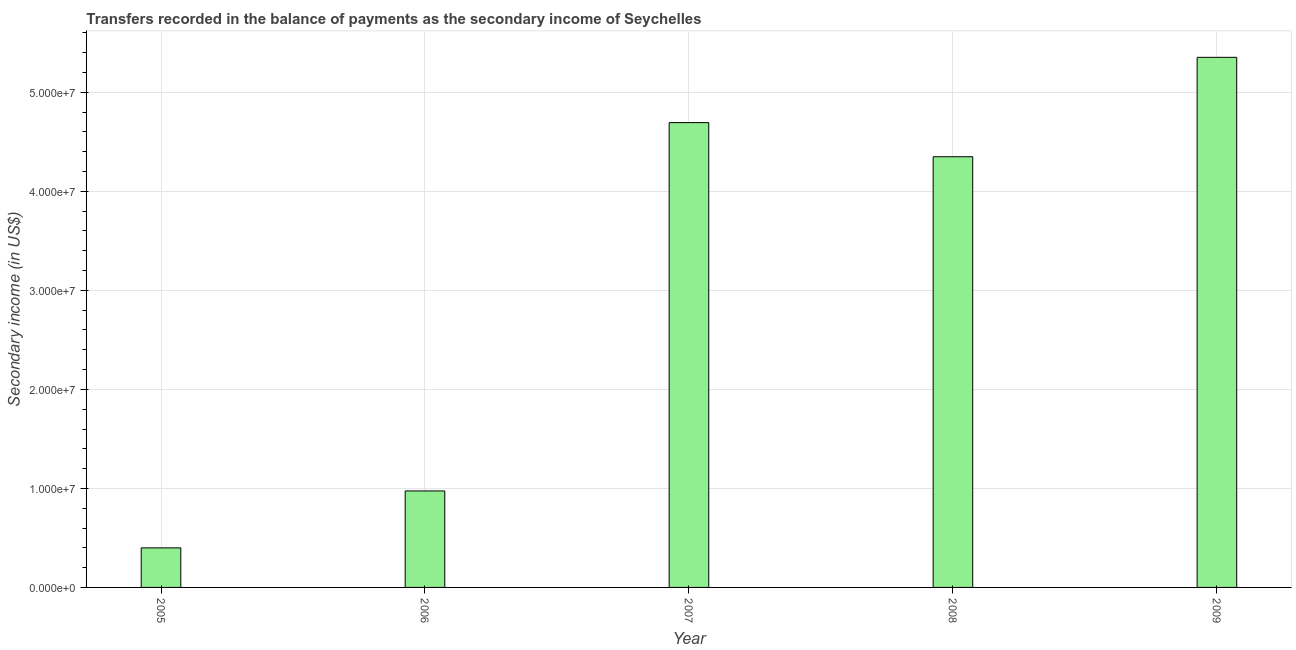Does the graph contain any zero values?
Give a very brief answer. No. What is the title of the graph?
Offer a terse response. Transfers recorded in the balance of payments as the secondary income of Seychelles. What is the label or title of the Y-axis?
Make the answer very short. Secondary income (in US$). What is the amount of secondary income in 2007?
Offer a terse response. 4.69e+07. Across all years, what is the maximum amount of secondary income?
Offer a terse response. 5.35e+07. Across all years, what is the minimum amount of secondary income?
Provide a short and direct response. 3.99e+06. In which year was the amount of secondary income maximum?
Keep it short and to the point. 2009. What is the sum of the amount of secondary income?
Offer a very short reply. 1.58e+08. What is the difference between the amount of secondary income in 2007 and 2009?
Make the answer very short. -6.59e+06. What is the average amount of secondary income per year?
Make the answer very short. 3.15e+07. What is the median amount of secondary income?
Make the answer very short. 4.35e+07. What is the ratio of the amount of secondary income in 2006 to that in 2009?
Provide a succinct answer. 0.18. What is the difference between the highest and the second highest amount of secondary income?
Make the answer very short. 6.59e+06. What is the difference between the highest and the lowest amount of secondary income?
Your answer should be compact. 4.95e+07. In how many years, is the amount of secondary income greater than the average amount of secondary income taken over all years?
Make the answer very short. 3. What is the difference between two consecutive major ticks on the Y-axis?
Make the answer very short. 1.00e+07. What is the Secondary income (in US$) of 2005?
Make the answer very short. 3.99e+06. What is the Secondary income (in US$) in 2006?
Offer a very short reply. 9.75e+06. What is the Secondary income (in US$) of 2007?
Make the answer very short. 4.69e+07. What is the Secondary income (in US$) of 2008?
Your response must be concise. 4.35e+07. What is the Secondary income (in US$) of 2009?
Give a very brief answer. 5.35e+07. What is the difference between the Secondary income (in US$) in 2005 and 2006?
Provide a short and direct response. -5.75e+06. What is the difference between the Secondary income (in US$) in 2005 and 2007?
Provide a short and direct response. -4.29e+07. What is the difference between the Secondary income (in US$) in 2005 and 2008?
Keep it short and to the point. -3.95e+07. What is the difference between the Secondary income (in US$) in 2005 and 2009?
Make the answer very short. -4.95e+07. What is the difference between the Secondary income (in US$) in 2006 and 2007?
Your answer should be compact. -3.72e+07. What is the difference between the Secondary income (in US$) in 2006 and 2008?
Make the answer very short. -3.38e+07. What is the difference between the Secondary income (in US$) in 2006 and 2009?
Your response must be concise. -4.38e+07. What is the difference between the Secondary income (in US$) in 2007 and 2008?
Keep it short and to the point. 3.44e+06. What is the difference between the Secondary income (in US$) in 2007 and 2009?
Provide a succinct answer. -6.59e+06. What is the difference between the Secondary income (in US$) in 2008 and 2009?
Your answer should be compact. -1.00e+07. What is the ratio of the Secondary income (in US$) in 2005 to that in 2006?
Your answer should be very brief. 0.41. What is the ratio of the Secondary income (in US$) in 2005 to that in 2007?
Provide a short and direct response. 0.09. What is the ratio of the Secondary income (in US$) in 2005 to that in 2008?
Ensure brevity in your answer.  0.09. What is the ratio of the Secondary income (in US$) in 2005 to that in 2009?
Provide a succinct answer. 0.07. What is the ratio of the Secondary income (in US$) in 2006 to that in 2007?
Offer a very short reply. 0.21. What is the ratio of the Secondary income (in US$) in 2006 to that in 2008?
Offer a very short reply. 0.22. What is the ratio of the Secondary income (in US$) in 2006 to that in 2009?
Provide a short and direct response. 0.18. What is the ratio of the Secondary income (in US$) in 2007 to that in 2008?
Offer a terse response. 1.08. What is the ratio of the Secondary income (in US$) in 2007 to that in 2009?
Your response must be concise. 0.88. What is the ratio of the Secondary income (in US$) in 2008 to that in 2009?
Your answer should be compact. 0.81. 